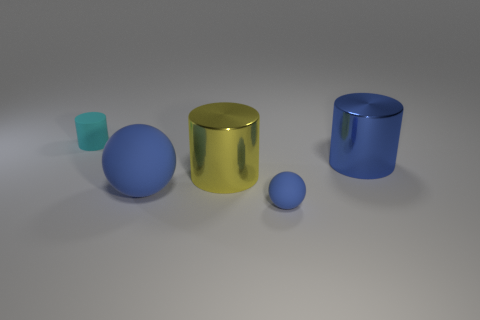Subtract all yellow shiny cylinders. How many cylinders are left? 2 Subtract all blue cylinders. How many cylinders are left? 2 Add 1 rubber things. How many objects exist? 6 Subtract all cylinders. How many objects are left? 2 Subtract 3 cylinders. How many cylinders are left? 0 Subtract all cyan cylinders. Subtract all big things. How many objects are left? 1 Add 3 cyan cylinders. How many cyan cylinders are left? 4 Add 4 shiny cylinders. How many shiny cylinders exist? 6 Subtract 1 yellow cylinders. How many objects are left? 4 Subtract all gray spheres. Subtract all green cylinders. How many spheres are left? 2 